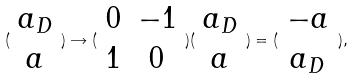Convert formula to latex. <formula><loc_0><loc_0><loc_500><loc_500>( \begin{array} { c } a _ { D } \\ a \end{array} ) \rightarrow ( \begin{array} { c c } 0 & - 1 \\ 1 & 0 \end{array} ) ( \begin{array} { c } a _ { D } \\ a \end{array} ) = ( \begin{array} { c } - a \\ a _ { D } \end{array} ) ,</formula> 